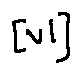<formula> <loc_0><loc_0><loc_500><loc_500>[ v l ]</formula> 